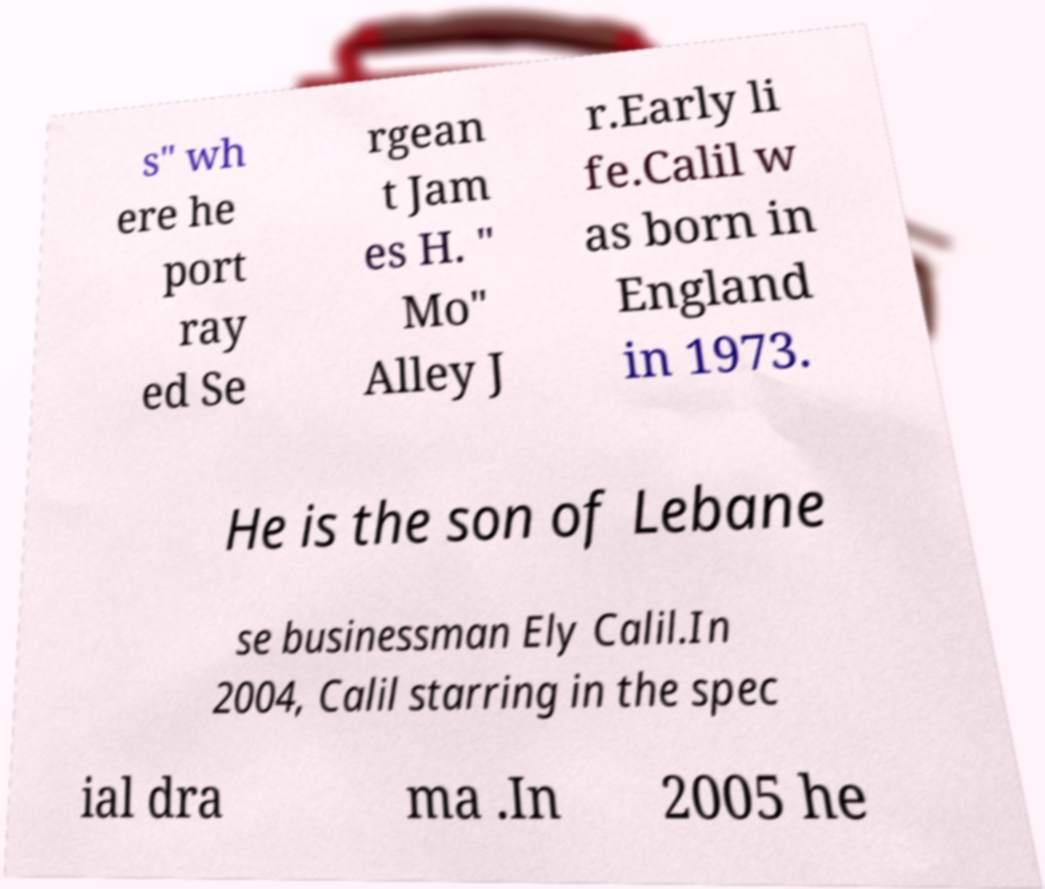Could you extract and type out the text from this image? s" wh ere he port ray ed Se rgean t Jam es H. " Mo" Alley J r.Early li fe.Calil w as born in England in 1973. He is the son of Lebane se businessman Ely Calil.In 2004, Calil starring in the spec ial dra ma .In 2005 he 